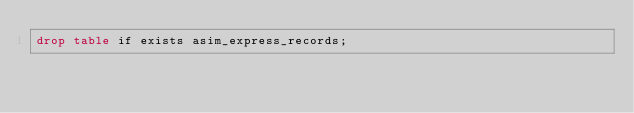<code> <loc_0><loc_0><loc_500><loc_500><_SQL_>drop table if exists asim_express_records;
</code> 